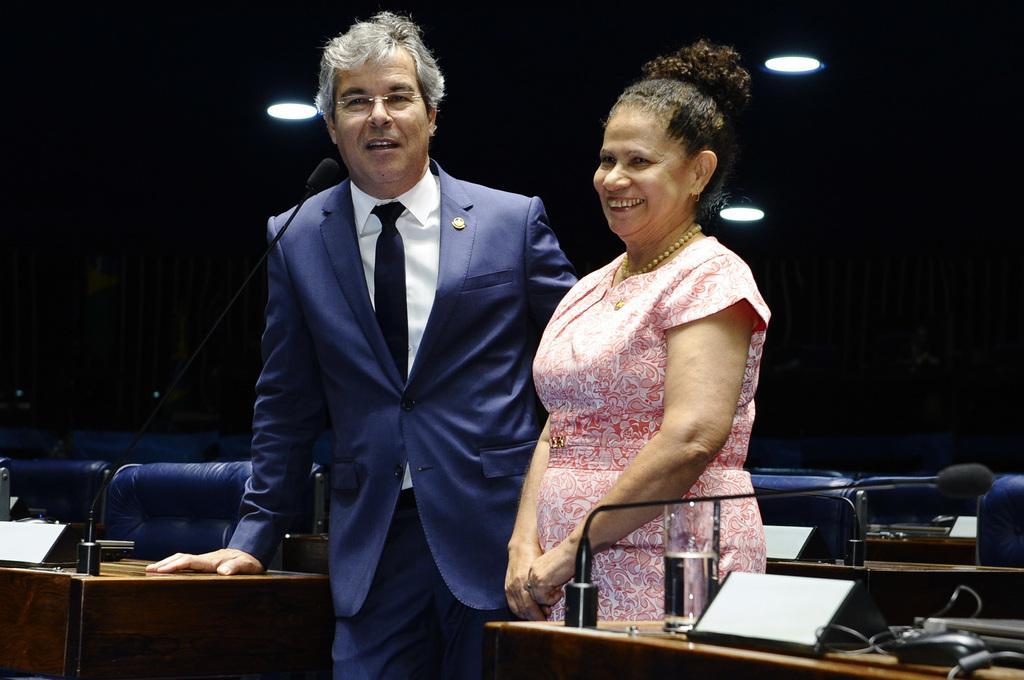In one or two sentences, can you explain what this image depicts? In this picture there are is a old couple in the front, smiling and giving a pose to the camera. In the front there is a table with microphone, water glass and cables. Behind there is a dark background. 